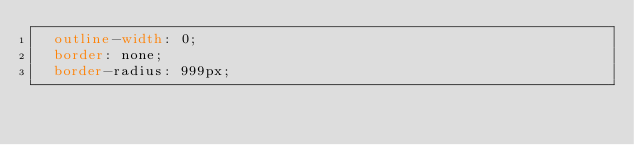Convert code to text. <code><loc_0><loc_0><loc_500><loc_500><_CSS_>  outline-width: 0;
  border: none;
  border-radius: 999px;</code> 